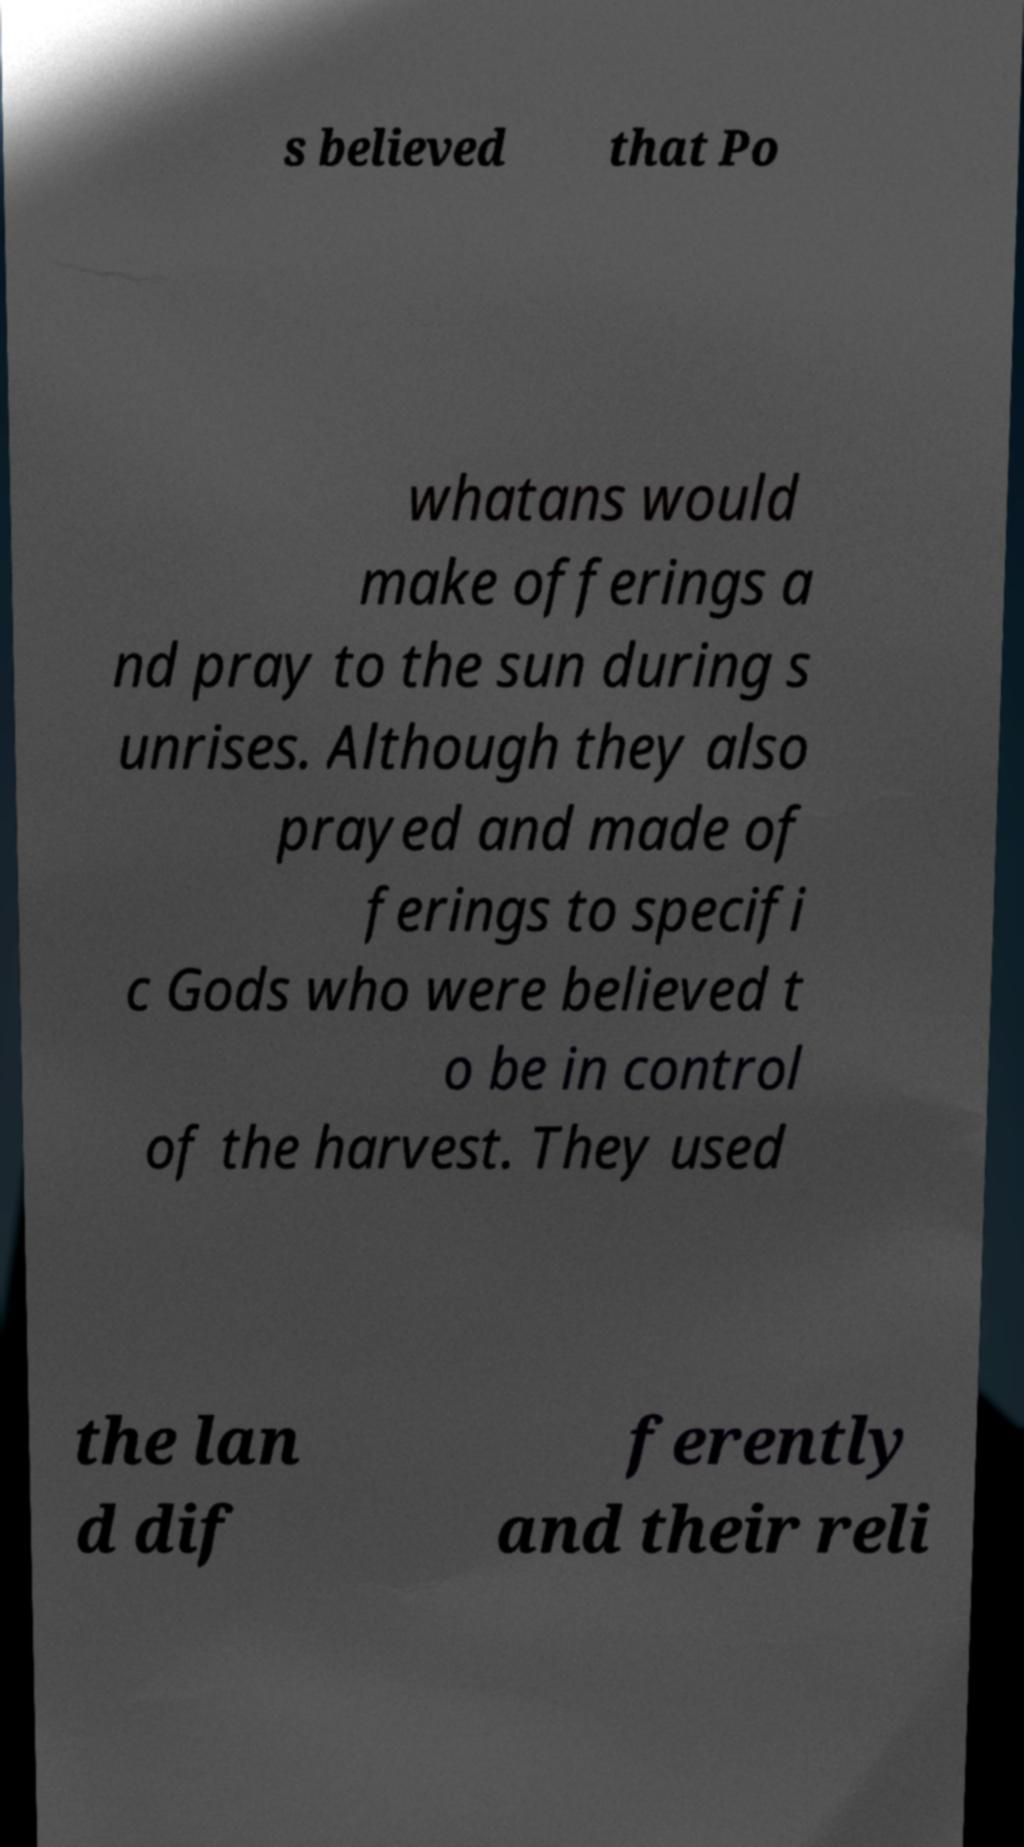Could you extract and type out the text from this image? s believed that Po whatans would make offerings a nd pray to the sun during s unrises. Although they also prayed and made of ferings to specifi c Gods who were believed t o be in control of the harvest. They used the lan d dif ferently and their reli 